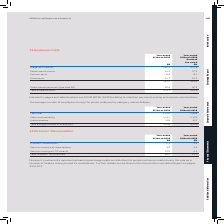According to Sophos Group's financial document, What do the directors' emoluments represent? all earnings and aggregate contributions to pension schemes made during the year as a Director of Sophos Group plc and its subsidiaries. The document states: "Directors’ emoluments represent all earnings and aggregate contributions to pension schemes made during the year as a Director of Sophos Group plc and..." Also, Where can further details of the directors' emoluments be found? in the Group’s Remuneration Report on pages 91 to 101. The document states: "nd its subsidiaries. Further details can be found in the Group’s Remuneration Report on pages 91 to 101...." Also, What are the components considered when calculating the total directors' remuneration? The document contains multiple relevant values: Directors’ emoluments, Gains on exercise of share options, Gains on vesting of LTIP awards. From the document: "Gains on vesting of LTIP awards 14.5 4.2 Gains on exercise of share options 3.6 3.5 Directors’ emoluments 2.3 3.3..." Additionally, In which year was the amount of Gains on exercise of share options larger? According to the financial document, 2019. The relevant text states: "Year-ended 31 March 2019 Year-ended 31 March 2018..." Also, can you calculate: What was the change in Total Directors’ remuneration in 2019 from 2018? Based on the calculation: 20.4-11.0, the result is 9.4 (in millions). This is based on the information: "Total Directors’ remuneration 20.4 11.0 Total Directors’ remuneration 20.4 11.0..." The key data points involved are: 11.0, 20.4. Also, can you calculate: What was the percentage change in Total Directors’ remuneration in 2019 from 2018? To answer this question, I need to perform calculations using the financial data. The calculation is: (20.4-11.0)/11.0, which equals 85.45 (percentage). This is based on the information: "Total Directors’ remuneration 20.4 11.0 Total Directors’ remuneration 20.4 11.0..." The key data points involved are: 11.0, 20.4. 